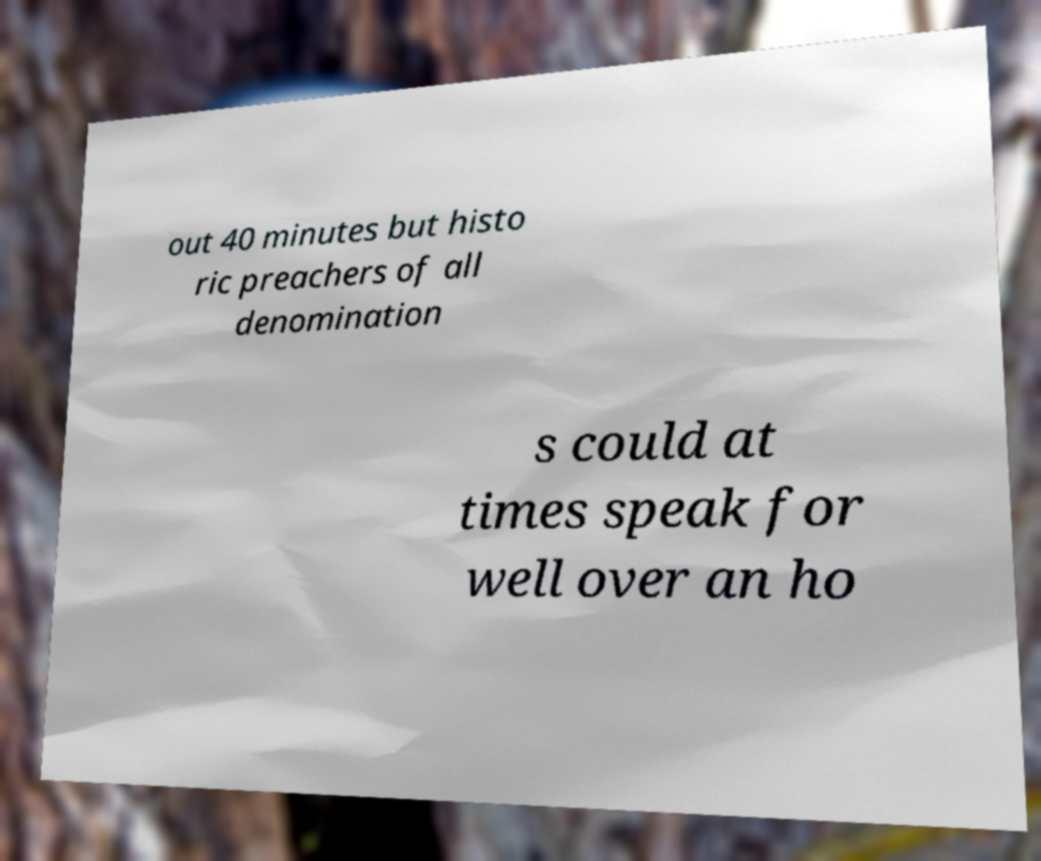There's text embedded in this image that I need extracted. Can you transcribe it verbatim? out 40 minutes but histo ric preachers of all denomination s could at times speak for well over an ho 